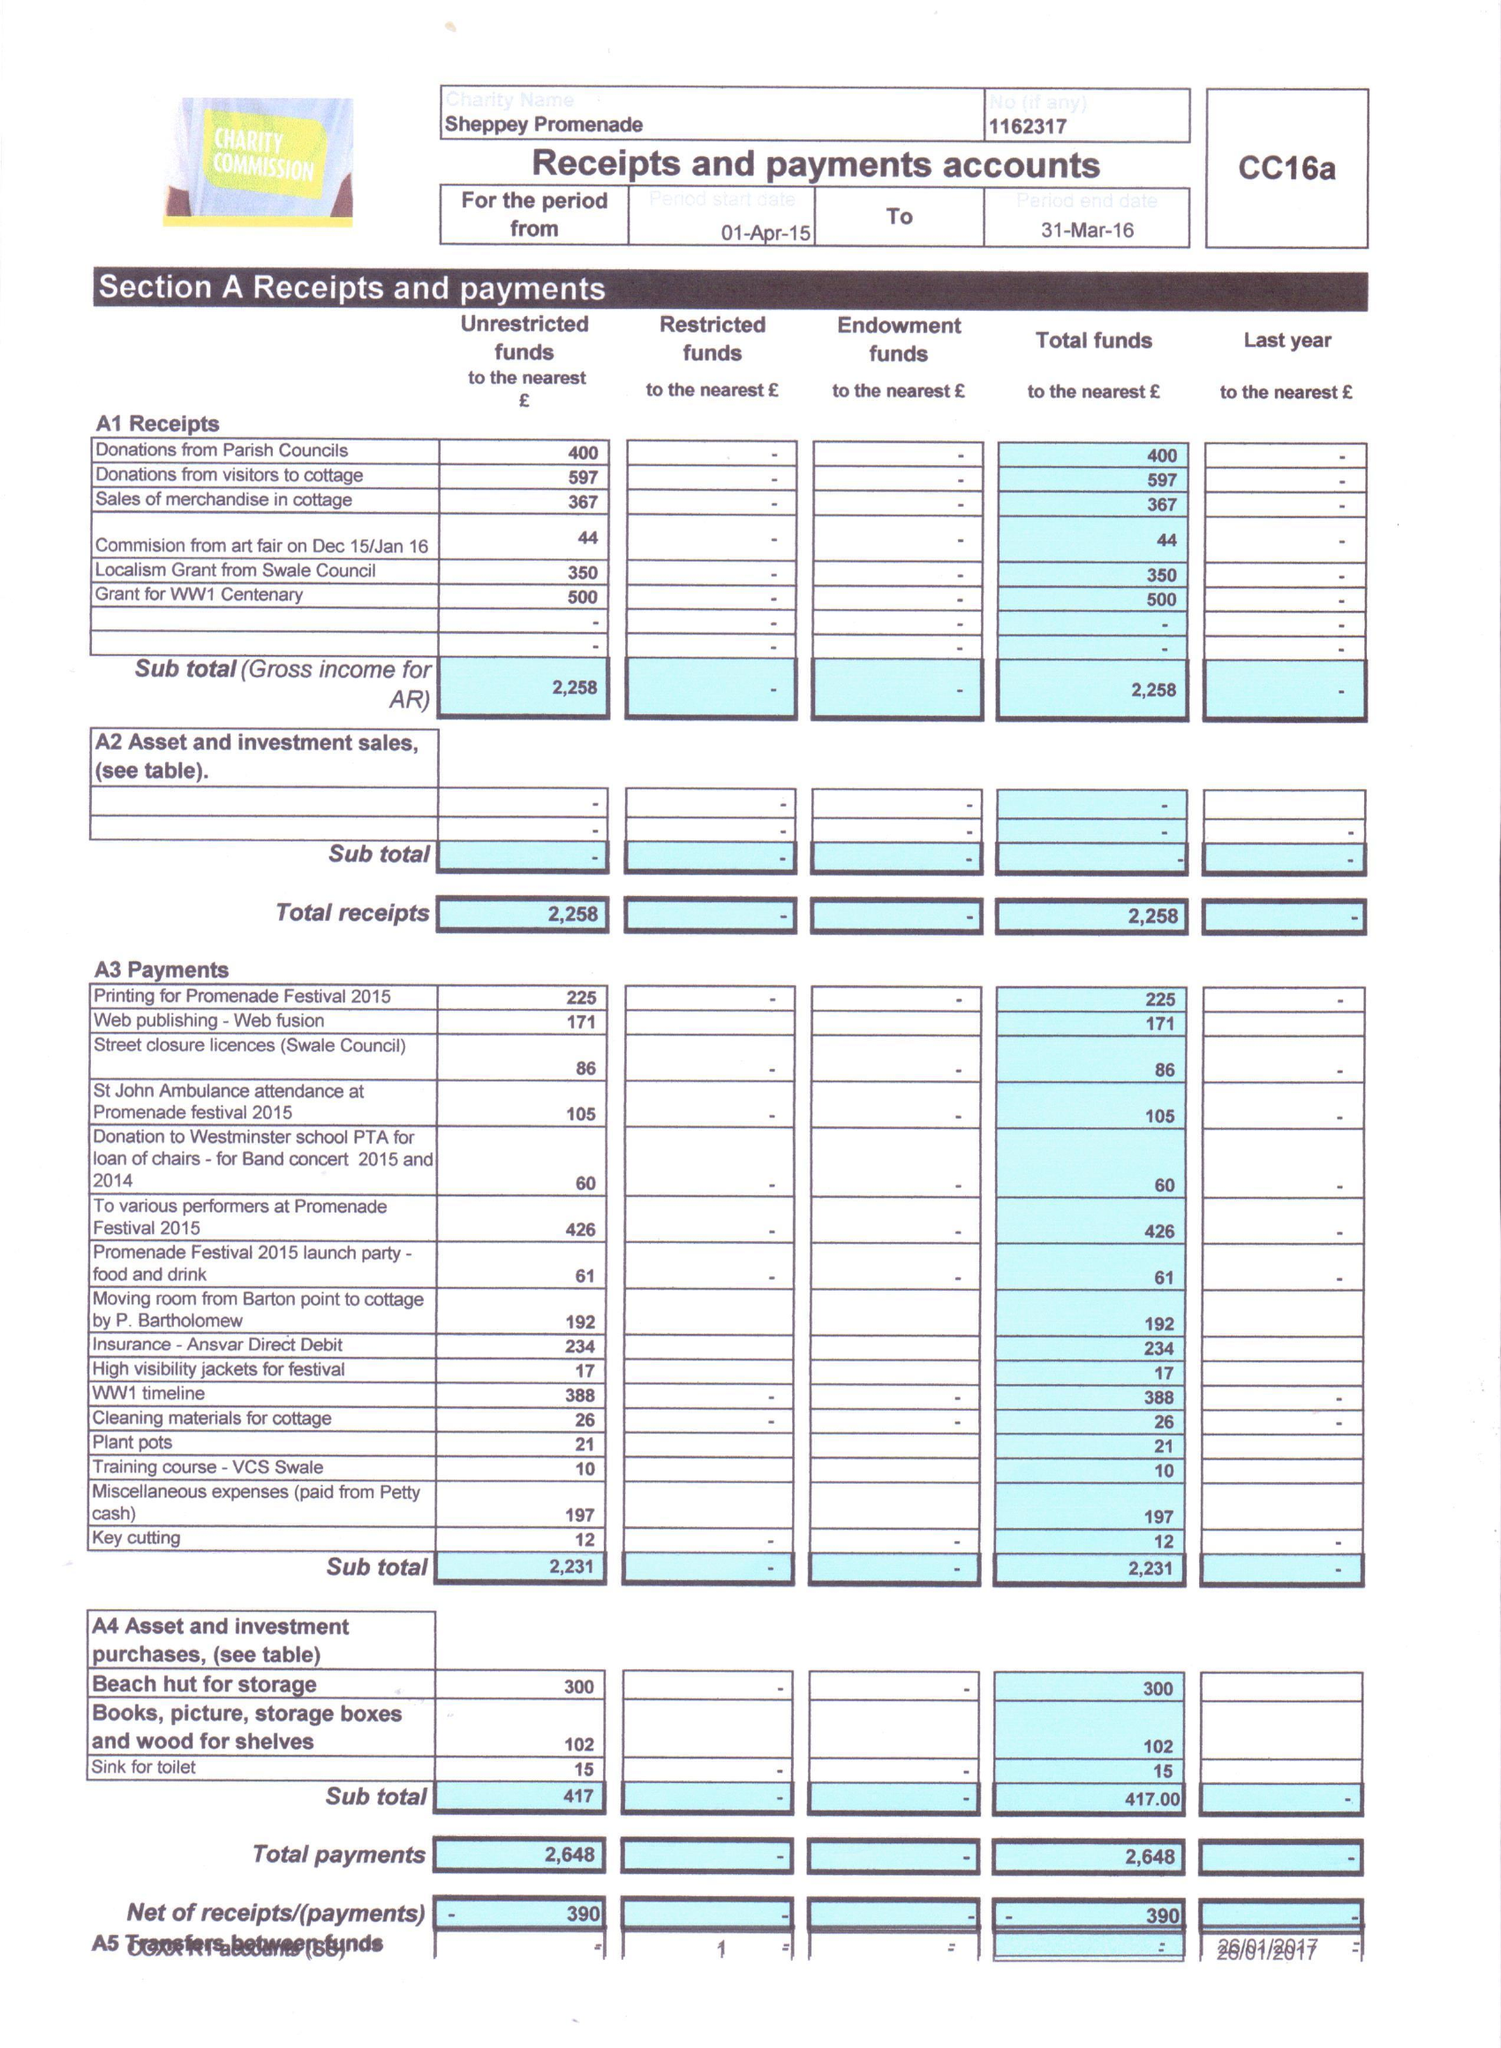What is the value for the spending_annually_in_british_pounds?
Answer the question using a single word or phrase. 2648.00 